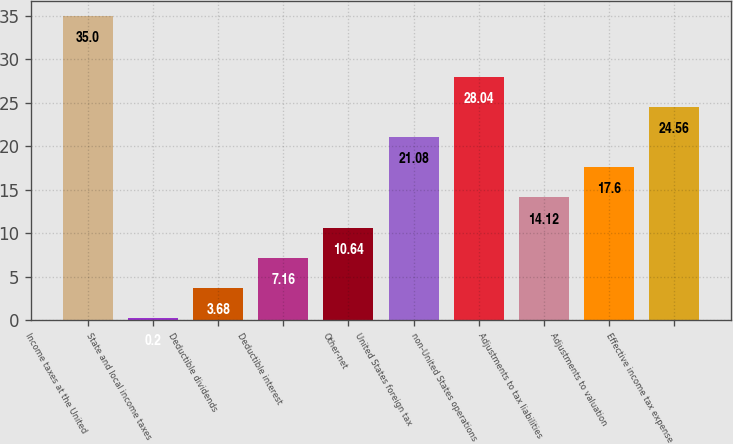Convert chart. <chart><loc_0><loc_0><loc_500><loc_500><bar_chart><fcel>Income taxes at the United<fcel>State and local income taxes<fcel>Deductible dividends<fcel>Deductible interest<fcel>Other-net<fcel>United States foreign tax<fcel>non-United States operations<fcel>Adjustments to tax liabilities<fcel>Adjustments to valuation<fcel>Effective income tax expense<nl><fcel>35<fcel>0.2<fcel>3.68<fcel>7.16<fcel>10.64<fcel>21.08<fcel>28.04<fcel>14.12<fcel>17.6<fcel>24.56<nl></chart> 